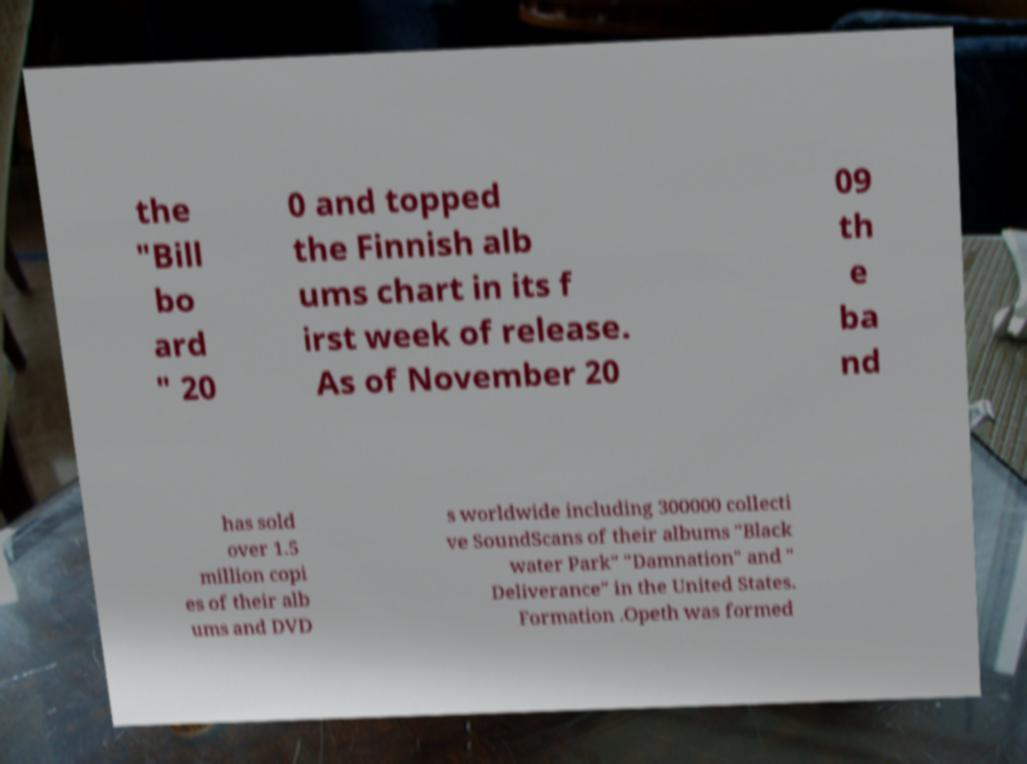Could you extract and type out the text from this image? the "Bill bo ard " 20 0 and topped the Finnish alb ums chart in its f irst week of release. As of November 20 09 th e ba nd has sold over 1.5 million copi es of their alb ums and DVD s worldwide including 300000 collecti ve SoundScans of their albums "Black water Park" "Damnation" and " Deliverance" in the United States. Formation .Opeth was formed 